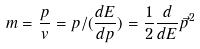<formula> <loc_0><loc_0><loc_500><loc_500>m = \frac { p } { v } = p / ( \frac { d E } { d p } ) = \frac { 1 } { 2 } \frac { d } { d E } \vec { p } ^ { 2 }</formula> 